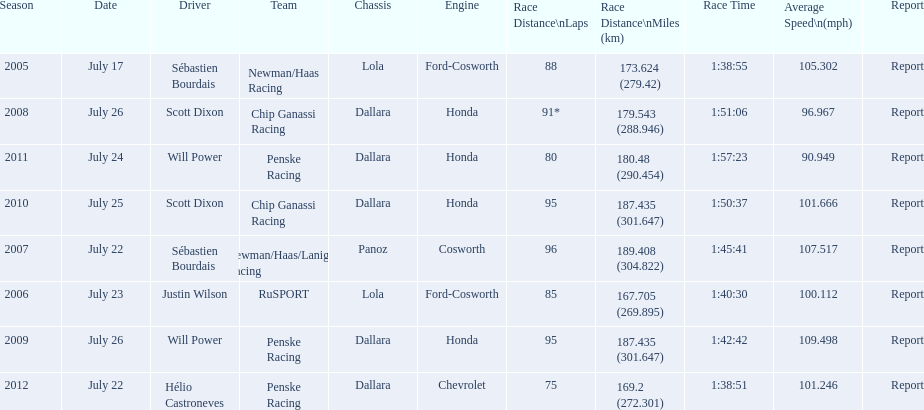What is the total number dallara chassis listed in the table? 5. 